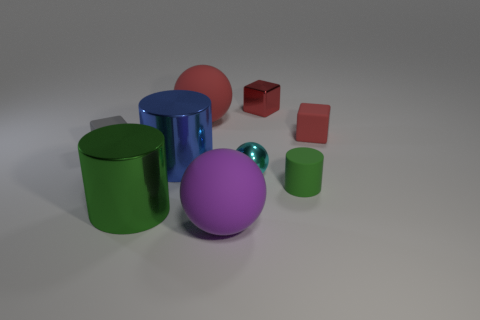Subtract all brown balls. How many red blocks are left? 2 Subtract 1 cubes. How many cubes are left? 2 Subtract all metal cylinders. How many cylinders are left? 1 Add 9 tiny green matte objects. How many tiny green matte objects exist? 10 Subtract 0 brown cylinders. How many objects are left? 9 Subtract all cylinders. How many objects are left? 6 Subtract all brown balls. Subtract all brown cylinders. How many balls are left? 3 Subtract all gray matte things. Subtract all balls. How many objects are left? 5 Add 5 metallic cylinders. How many metallic cylinders are left? 7 